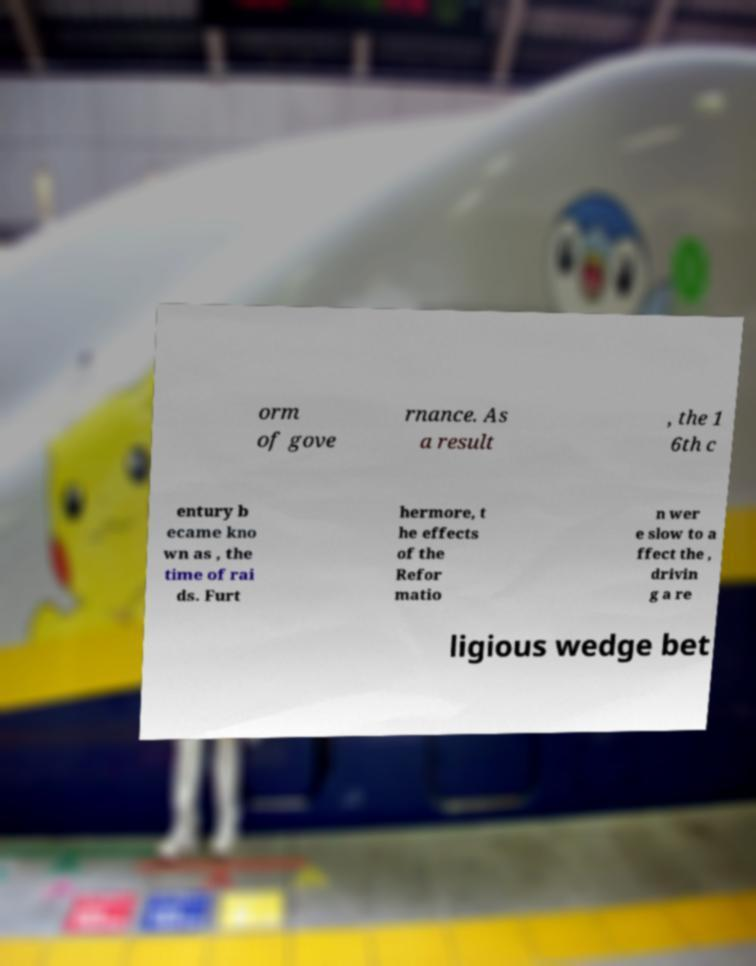Can you accurately transcribe the text from the provided image for me? orm of gove rnance. As a result , the 1 6th c entury b ecame kno wn as , the time of rai ds. Furt hermore, t he effects of the Refor matio n wer e slow to a ffect the , drivin g a re ligious wedge bet 